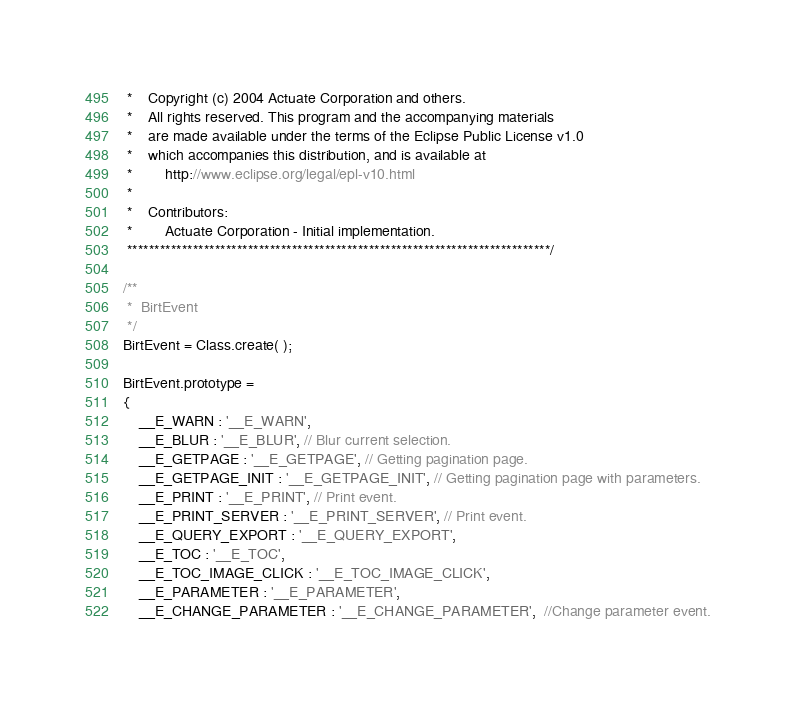<code> <loc_0><loc_0><loc_500><loc_500><_JavaScript_> *	Copyright (c) 2004 Actuate Corporation and others.
 *	All rights reserved. This program and the accompanying materials 
 *	are made available under the terms of the Eclipse Public License v1.0
 *	which accompanies this distribution, and is available at
 *		http://www.eclipse.org/legal/epl-v10.html
 *	
 *	Contributors:
 *		Actuate Corporation - Initial implementation.
 *****************************************************************************/
 
/**
 *	BirtEvent
 */
BirtEvent = Class.create( );

BirtEvent.prototype =
{
	__E_WARN : '__E_WARN',
	__E_BLUR : '__E_BLUR', // Blur current selection.
	__E_GETPAGE : '__E_GETPAGE', // Getting pagination page.
	__E_GETPAGE_INIT : '__E_GETPAGE_INIT', // Getting pagination page with parameters.
	__E_PRINT : '__E_PRINT', // Print event.
	__E_PRINT_SERVER : '__E_PRINT_SERVER', // Print event.
	__E_QUERY_EXPORT : '__E_QUERY_EXPORT',
	__E_TOC : '__E_TOC',
	__E_TOC_IMAGE_CLICK : '__E_TOC_IMAGE_CLICK',
	__E_PARAMETER : '__E_PARAMETER',
	__E_CHANGE_PARAMETER : '__E_CHANGE_PARAMETER',  //Change parameter event.</code> 